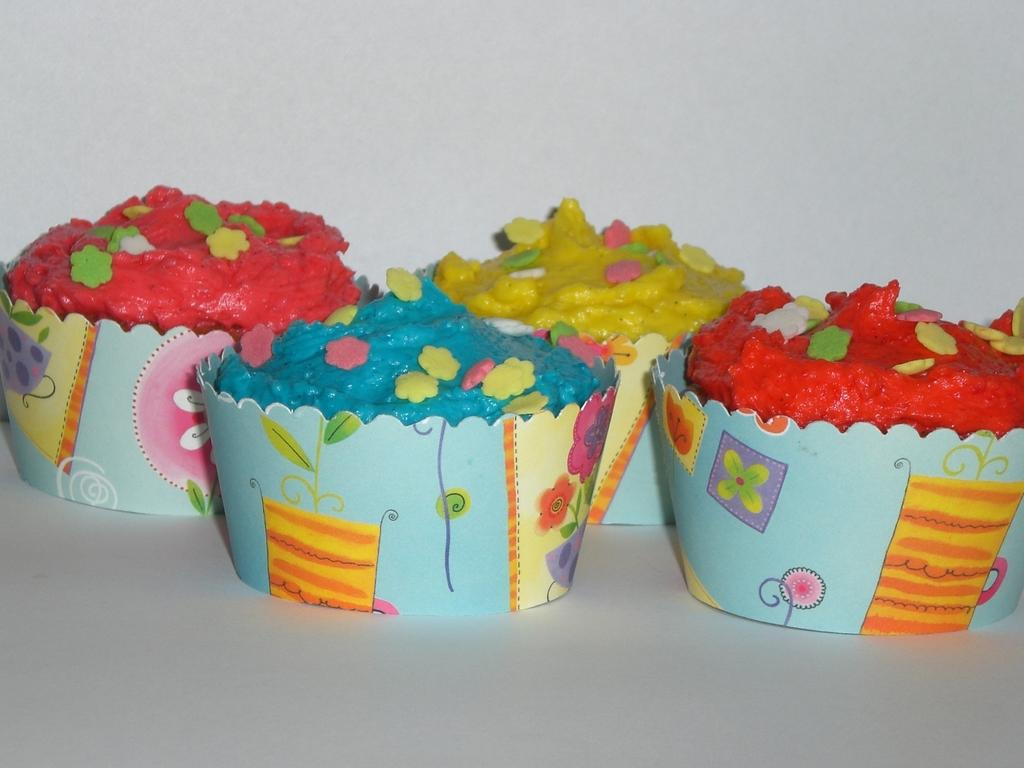What is located in the center of the image? There is a table in the center of the image. What is placed on the table? There are four cupcakes on the table. Can you describe the appearance of the cupcakes? The cupcakes are in different colors. What can be seen in the background of the image? There is a wall in the background of the image. What type of fan is visible in the image? There is no fan present in the image. What kind of toys are scattered around the table in the image? There are no toys present in the image; it only features a table with cupcakes and a wall in the background. 